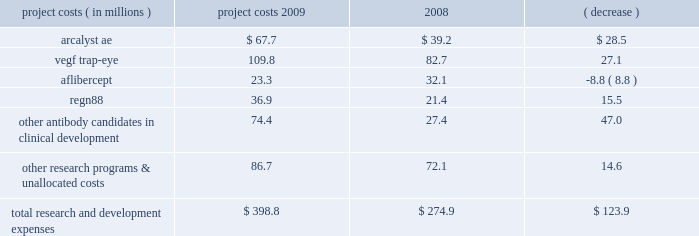We prepare estimates of research and development costs for projects in clinical development , which include direct costs and allocations of certain costs such as indirect labor , non-cash compensation expense , and manufacturing and other costs related to activities that benefit multiple projects , and , under our collaboration with bayer healthcare , the portion of bayer healthcare 2019s vegf trap-eye development expenses that we are obligated to reimburse .
Our estimates of research and development costs for clinical development programs are shown below : project costs year ended december 31 , increase ( decrease ) ( in millions ) 2009 2008 .
For the reasons described above in results of operations for the years ended december 31 , 2010 and 2009 , under the caption 201cresearch and development expenses 201d , and due to the variability in the costs necessary to develop a pharmaceutical product and the uncertainties related to future indications to be studied , the estimated cost and scope of the projects , and our ultimate ability to obtain governmental approval for commercialization , accurate and meaningful estimates of the total cost to bring our product candidates to market are not available .
Similarly , we are currently unable to reasonably estimate if our product candidates will generate material product revenues and net cash inflows .
In 2008 , we received fda approval for arcalyst ae for the treatment of caps , a group of rare , inherited auto-inflammatory diseases that affect a very small group of people .
We currently do not expect to generate material product revenues and net cash inflows from the sale of arcalyst ae for the treatment of caps .
Selling , general , and administrative expenses selling , general , and administrative expenses increased to $ 52.9 million in 2009 from $ 48.9 million in 2008 .
In 2009 , we incurred ( i ) higher compensation expense , ( ii ) higher patent-related costs , ( iii ) higher facility-related costs due primarily to increases in administrative headcount , and ( iv ) higher patient assistance costs related to arcalyst ae .
These increases were partly offset by ( i ) lower marketing costs related to arcalyst ae , ( ii ) a decrease in administrative recruitment costs , and ( iii ) lower professional fees related to various corporate matters .
Cost of goods sold during 2008 , we began recognizing revenue and cost of goods sold from net product sales of arcalyst ae .
Cost of goods sold in 2009 and 2008 was $ 1.7 million and $ 0.9 million , respectively , and consisted primarily of royalties and other period costs related to arcalyst ae commercial supplies .
In 2009 and 2008 , arcalyst ae shipments to our customers consisted of supplies of inventory manufactured and expensed as research and development costs prior to fda approval in 2008 ; therefore , the costs of these supplies were not included in costs of goods sold .
Other income and expense investment income decreased to $ 4.5 million in 2009 from $ 18.2 million in 2008 , due primarily to lower yields on , and lower balances of , cash and marketable securities .
In addition , in 2009 and 2008 , deterioration in the credit quality of specific marketable securities in our investment portfolio subjected us to the risk of not being able to recover these securities 2019 carrying values .
As a result , in 2009 and 2008 , we recognized charges of $ 0.1 million and $ 2.5 million , respectively , related to these securities , which we considered to be other than temporarily impaired .
In 2009 and 2008 , these charges were either wholly or partly offset by realized gains of $ 0.2 million and $ 1.2 million , respectively , on sales of marketable securities during the year. .
What was the percentage change in research and development costs related to arcalyst ae from 2008 to 2009? 
Computations: (28.5 / 39.2)
Answer: 0.72704. We prepare estimates of research and development costs for projects in clinical development , which include direct costs and allocations of certain costs such as indirect labor , non-cash compensation expense , and manufacturing and other costs related to activities that benefit multiple projects , and , under our collaboration with bayer healthcare , the portion of bayer healthcare 2019s vegf trap-eye development expenses that we are obligated to reimburse .
Our estimates of research and development costs for clinical development programs are shown below : project costs year ended december 31 , increase ( decrease ) ( in millions ) 2009 2008 .
For the reasons described above in results of operations for the years ended december 31 , 2010 and 2009 , under the caption 201cresearch and development expenses 201d , and due to the variability in the costs necessary to develop a pharmaceutical product and the uncertainties related to future indications to be studied , the estimated cost and scope of the projects , and our ultimate ability to obtain governmental approval for commercialization , accurate and meaningful estimates of the total cost to bring our product candidates to market are not available .
Similarly , we are currently unable to reasonably estimate if our product candidates will generate material product revenues and net cash inflows .
In 2008 , we received fda approval for arcalyst ae for the treatment of caps , a group of rare , inherited auto-inflammatory diseases that affect a very small group of people .
We currently do not expect to generate material product revenues and net cash inflows from the sale of arcalyst ae for the treatment of caps .
Selling , general , and administrative expenses selling , general , and administrative expenses increased to $ 52.9 million in 2009 from $ 48.9 million in 2008 .
In 2009 , we incurred ( i ) higher compensation expense , ( ii ) higher patent-related costs , ( iii ) higher facility-related costs due primarily to increases in administrative headcount , and ( iv ) higher patient assistance costs related to arcalyst ae .
These increases were partly offset by ( i ) lower marketing costs related to arcalyst ae , ( ii ) a decrease in administrative recruitment costs , and ( iii ) lower professional fees related to various corporate matters .
Cost of goods sold during 2008 , we began recognizing revenue and cost of goods sold from net product sales of arcalyst ae .
Cost of goods sold in 2009 and 2008 was $ 1.7 million and $ 0.9 million , respectively , and consisted primarily of royalties and other period costs related to arcalyst ae commercial supplies .
In 2009 and 2008 , arcalyst ae shipments to our customers consisted of supplies of inventory manufactured and expensed as research and development costs prior to fda approval in 2008 ; therefore , the costs of these supplies were not included in costs of goods sold .
Other income and expense investment income decreased to $ 4.5 million in 2009 from $ 18.2 million in 2008 , due primarily to lower yields on , and lower balances of , cash and marketable securities .
In addition , in 2009 and 2008 , deterioration in the credit quality of specific marketable securities in our investment portfolio subjected us to the risk of not being able to recover these securities 2019 carrying values .
As a result , in 2009 and 2008 , we recognized charges of $ 0.1 million and $ 2.5 million , respectively , related to these securities , which we considered to be other than temporarily impaired .
In 2009 and 2008 , these charges were either wholly or partly offset by realized gains of $ 0.2 million and $ 1.2 million , respectively , on sales of marketable securities during the year. .
What was the percentage change in research and development costs related to vegf trap-eye from 2008 to 2009? 
Computations: (27.1 / 82.7)
Answer: 0.32769. 